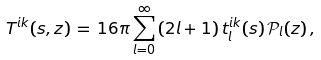<formula> <loc_0><loc_0><loc_500><loc_500>T ^ { i k } ( s , z ) \, = \, 1 6 \pi \sum _ { l = 0 } ^ { \infty } \, ( 2 l + 1 ) \, t _ { l } ^ { i k } ( s ) \, { \mathcal { P } } _ { l } ( z ) \, ,</formula> 